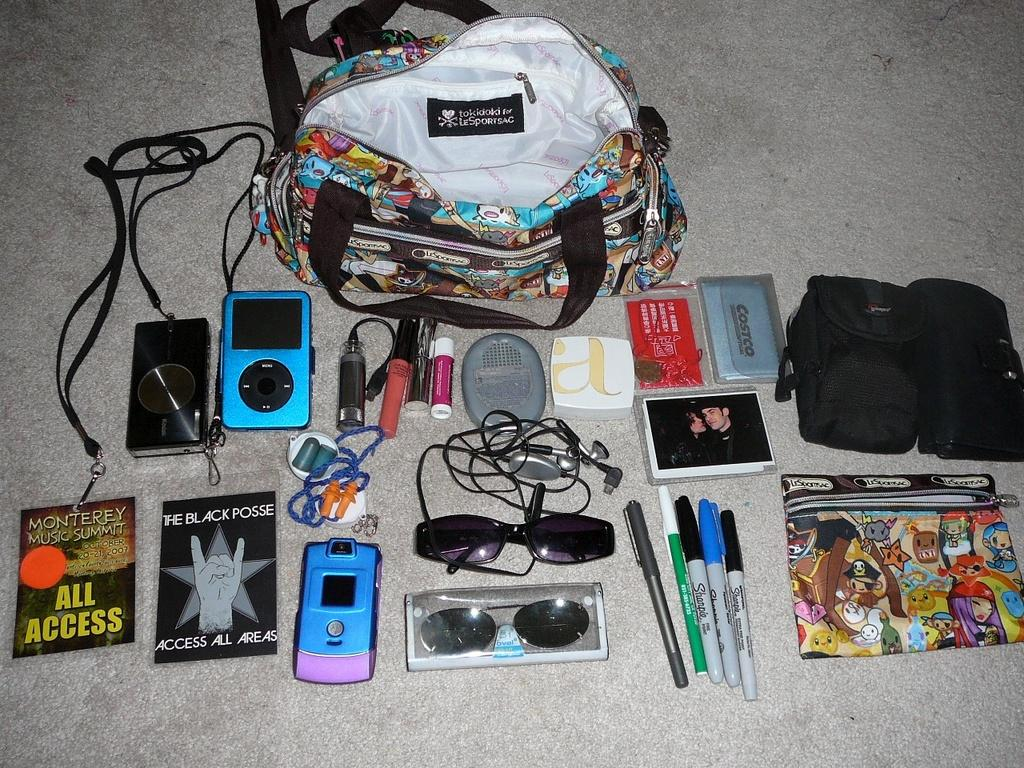What is one of the objects visible in the image? There is a backpack in the image. Can you describe the arrangement of objects in the image? There is a group of objects placed on the floor in the image. What type of chalk is being used by the creator in the image? There is no creator or chalk present in the image. Where is the place mentioned in the image? There is no specific place mentioned in the image. 